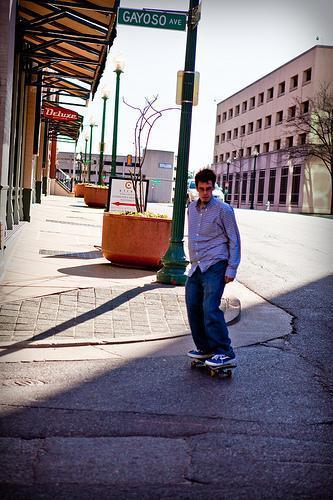How many men are there?
Give a very brief answer. 1. 